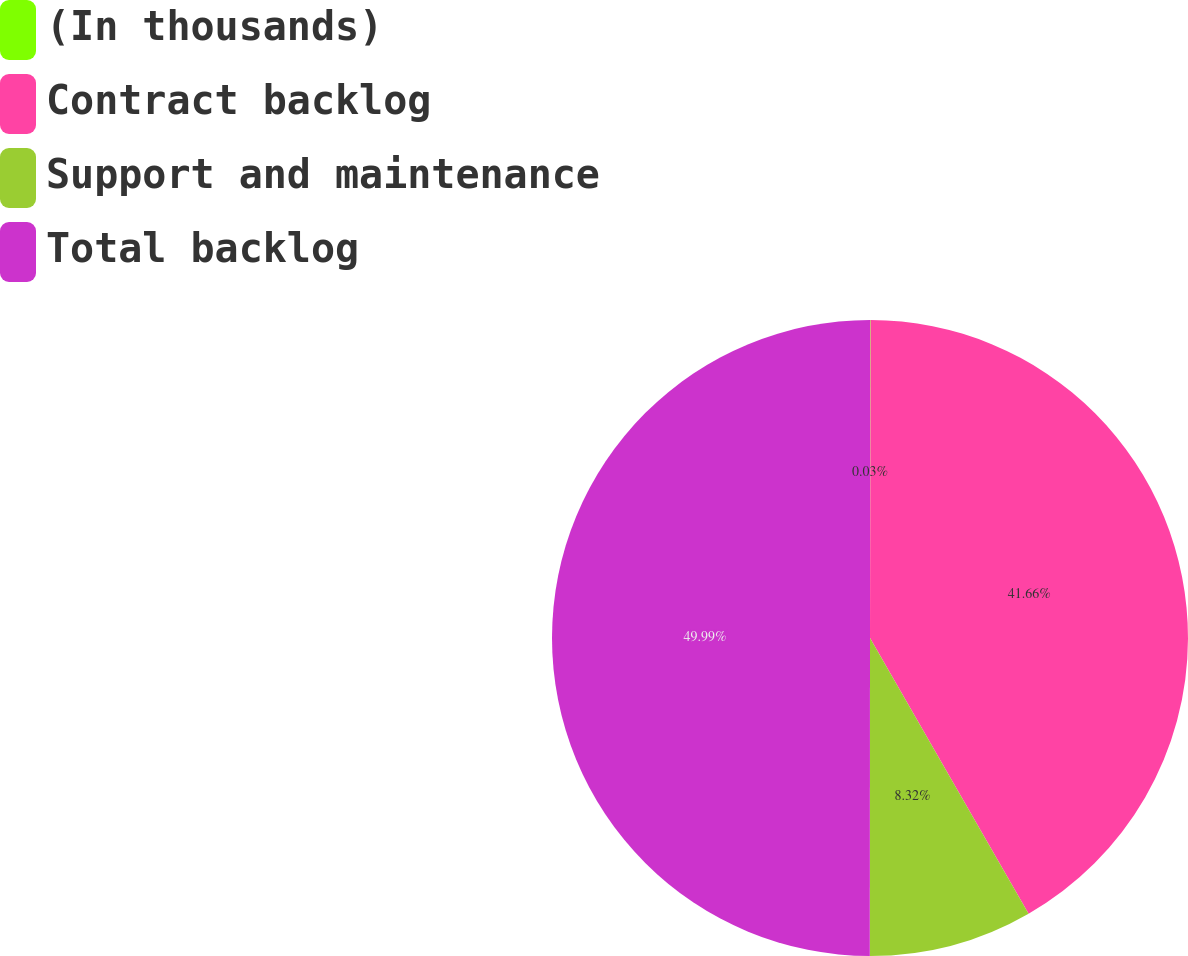Convert chart. <chart><loc_0><loc_0><loc_500><loc_500><pie_chart><fcel>(In thousands)<fcel>Contract backlog<fcel>Support and maintenance<fcel>Total backlog<nl><fcel>0.03%<fcel>41.66%<fcel>8.32%<fcel>49.99%<nl></chart> 